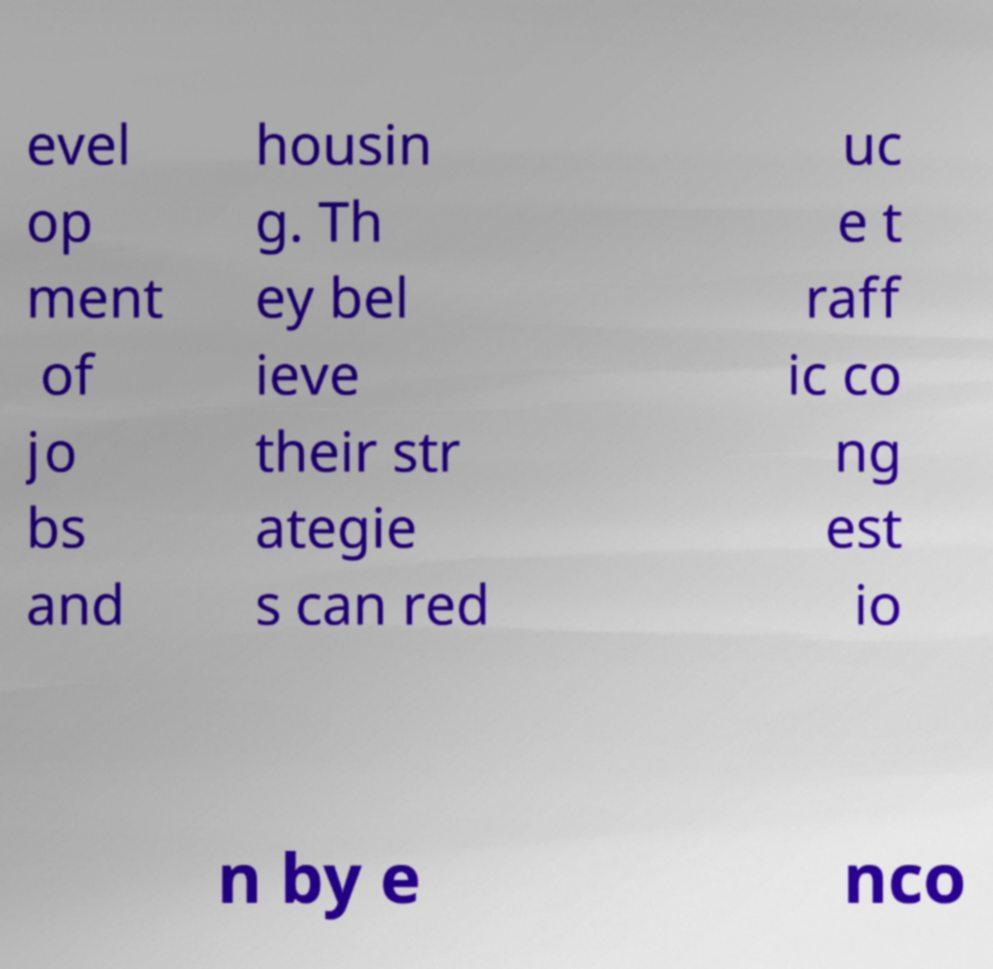Please read and relay the text visible in this image. What does it say? evel op ment of jo bs and housin g. Th ey bel ieve their str ategie s can red uc e t raff ic co ng est io n by e nco 